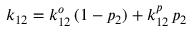Convert formula to latex. <formula><loc_0><loc_0><loc_500><loc_500>k _ { 1 2 } = k _ { 1 2 } ^ { o } \, ( 1 - p _ { 2 } ) + k _ { 1 2 } ^ { p } \, p _ { 2 }</formula> 